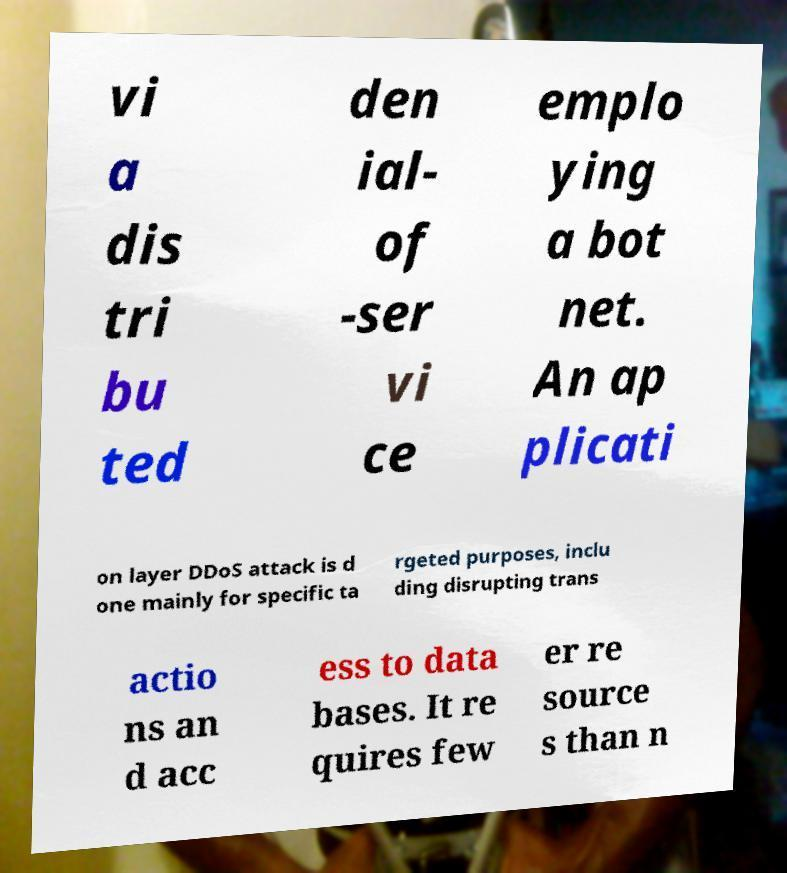Could you extract and type out the text from this image? vi a dis tri bu ted den ial- of -ser vi ce emplo ying a bot net. An ap plicati on layer DDoS attack is d one mainly for specific ta rgeted purposes, inclu ding disrupting trans actio ns an d acc ess to data bases. It re quires few er re source s than n 